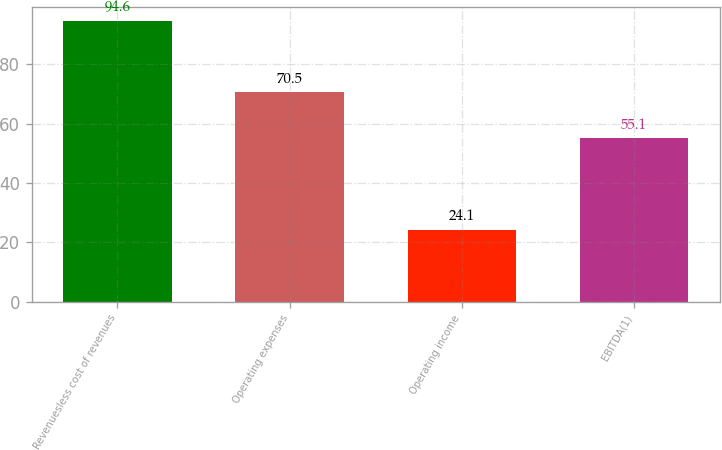Convert chart to OTSL. <chart><loc_0><loc_0><loc_500><loc_500><bar_chart><fcel>Revenuesless cost of revenues<fcel>Operating expenses<fcel>Operating income<fcel>EBITDA(1)<nl><fcel>94.6<fcel>70.5<fcel>24.1<fcel>55.1<nl></chart> 